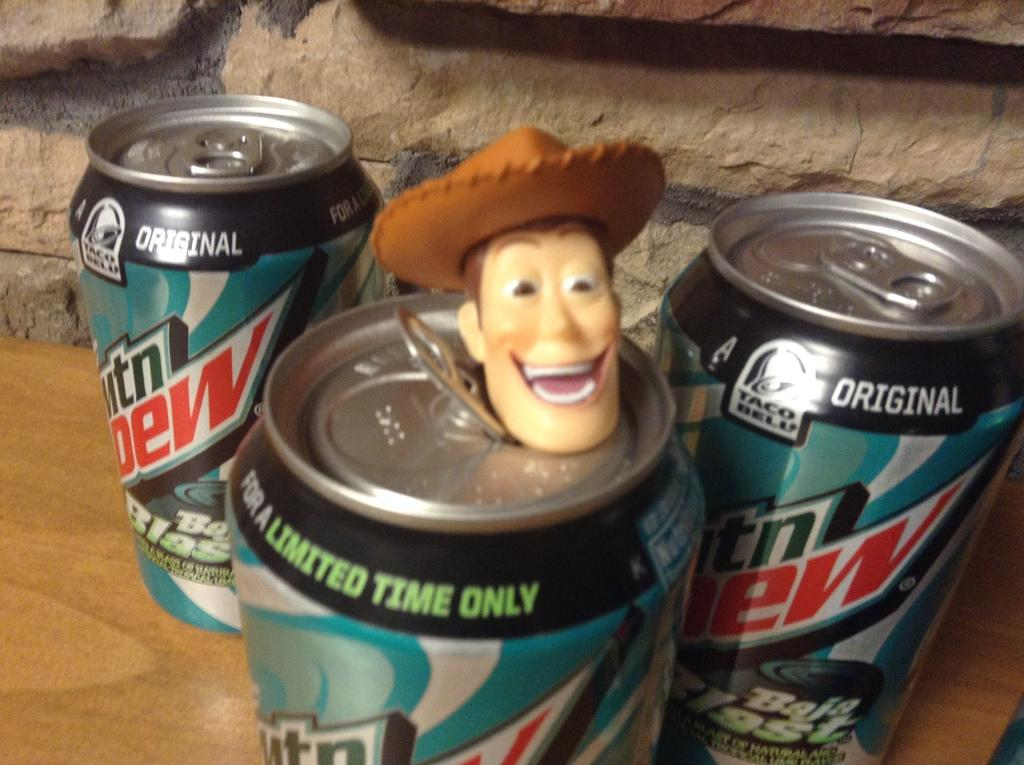How many tin cans are visible in the image? There are three tin cans in the image. What is on top of the middle tin can? A toy is present on the middle tin can. What can be found on the labels of the tin cans? The tin cans have labels with writing on them. What type of surface are the tin cans resting on? The tin cans are on a wooden surface. What type of disease can be seen affecting the cherries in the image? There are no cherries present in the image, so it is not possible to determine if any disease is affecting them. 